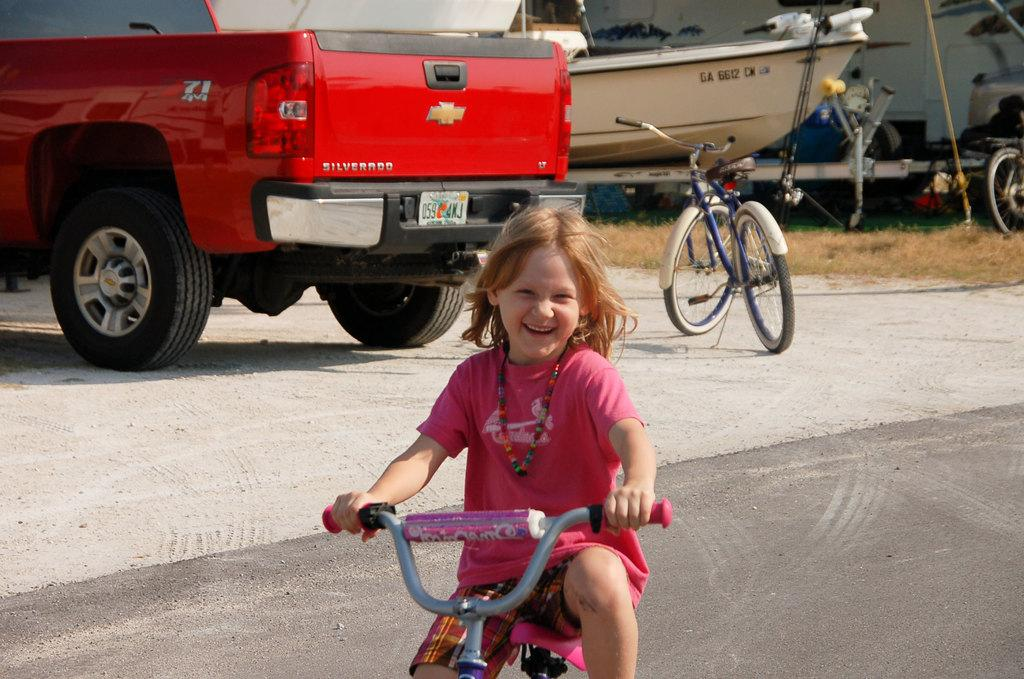Who is the main subject in the image? There is a girl in the image. What is the girl doing in the image? The girl is cycling a cycle. How does the girl appear to be feeling in the image? The girl has a smile on her face, indicating that she is happy. What can be seen in the background of the image? There are other cycles and vehicles visible in the background. What type of waves can be seen in the image? There are no waves present in the image; it features a girl cycling a cycle. Is the girl wearing a scarf in the image? There is no mention of a scarf in the image; the girl's clothing is not described. 